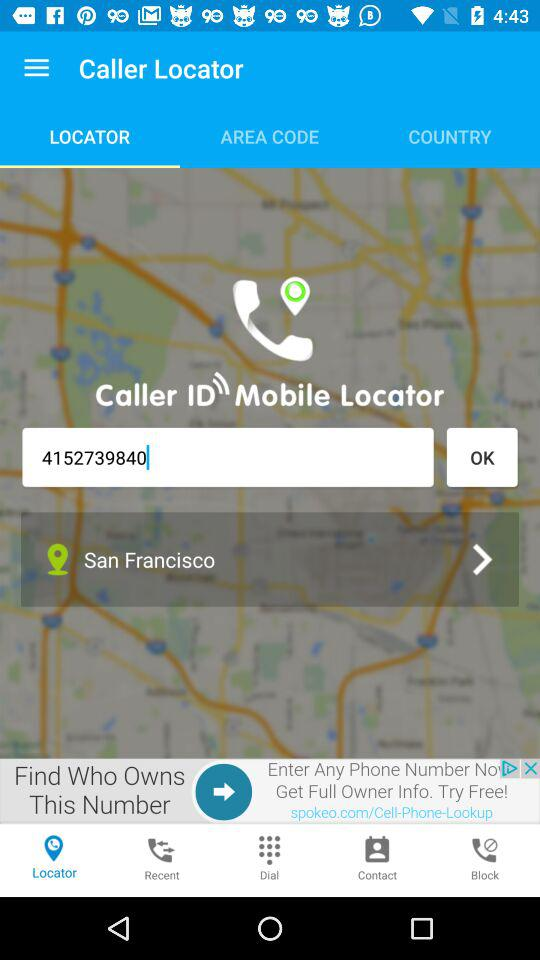How many digits are in the phone number that is being entered?
Answer the question using a single word or phrase. 10 